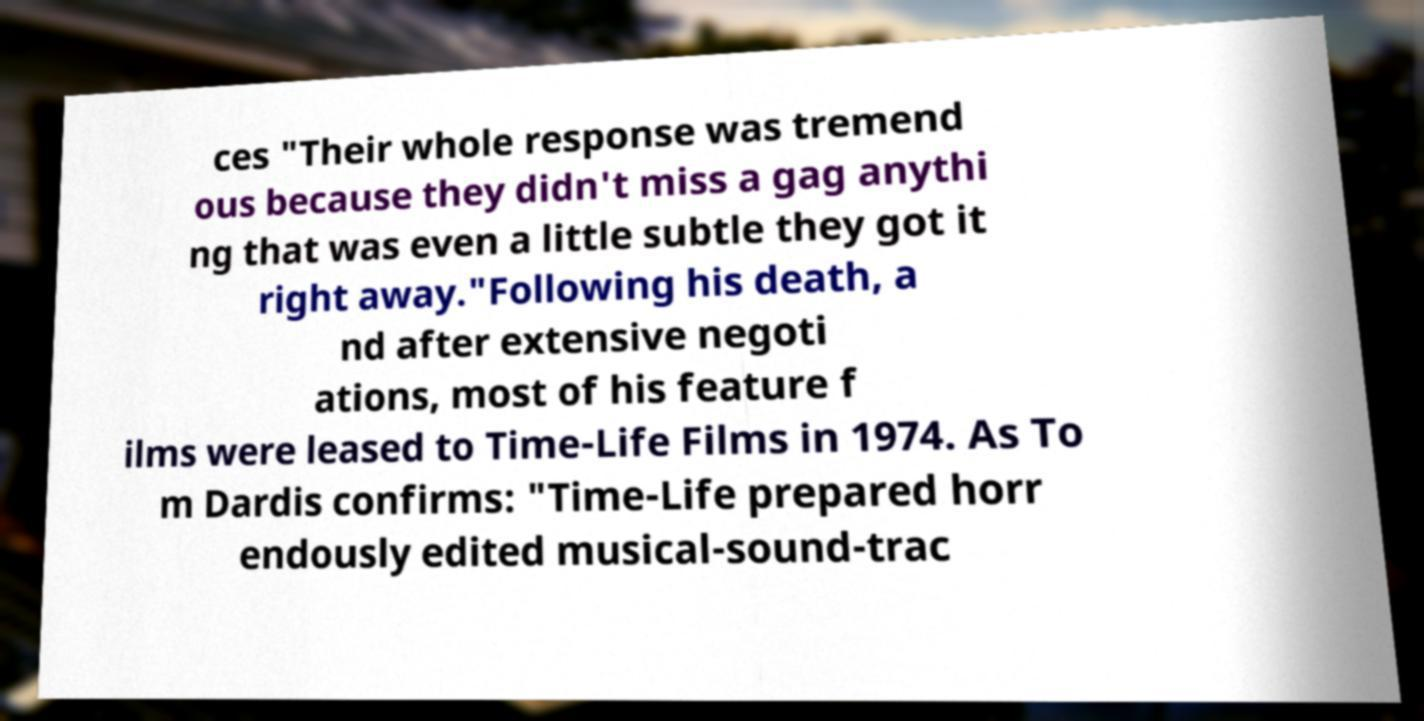For documentation purposes, I need the text within this image transcribed. Could you provide that? ces "Their whole response was tremend ous because they didn't miss a gag anythi ng that was even a little subtle they got it right away."Following his death, a nd after extensive negoti ations, most of his feature f ilms were leased to Time-Life Films in 1974. As To m Dardis confirms: "Time-Life prepared horr endously edited musical-sound-trac 